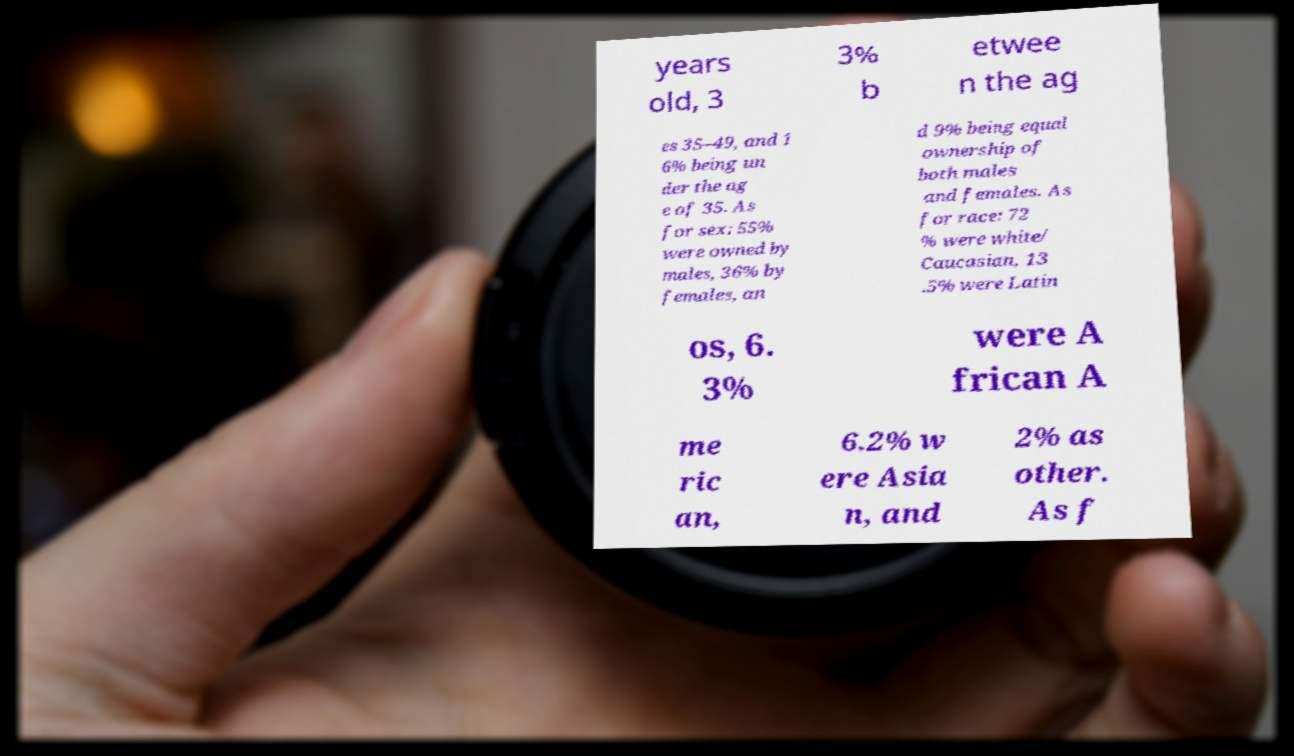Can you read and provide the text displayed in the image?This photo seems to have some interesting text. Can you extract and type it out for me? years old, 3 3% b etwee n the ag es 35–49, and 1 6% being un der the ag e of 35. As for sex: 55% were owned by males, 36% by females, an d 9% being equal ownership of both males and females. As for race: 72 % were white/ Caucasian, 13 .5% were Latin os, 6. 3% were A frican A me ric an, 6.2% w ere Asia n, and 2% as other. As f 